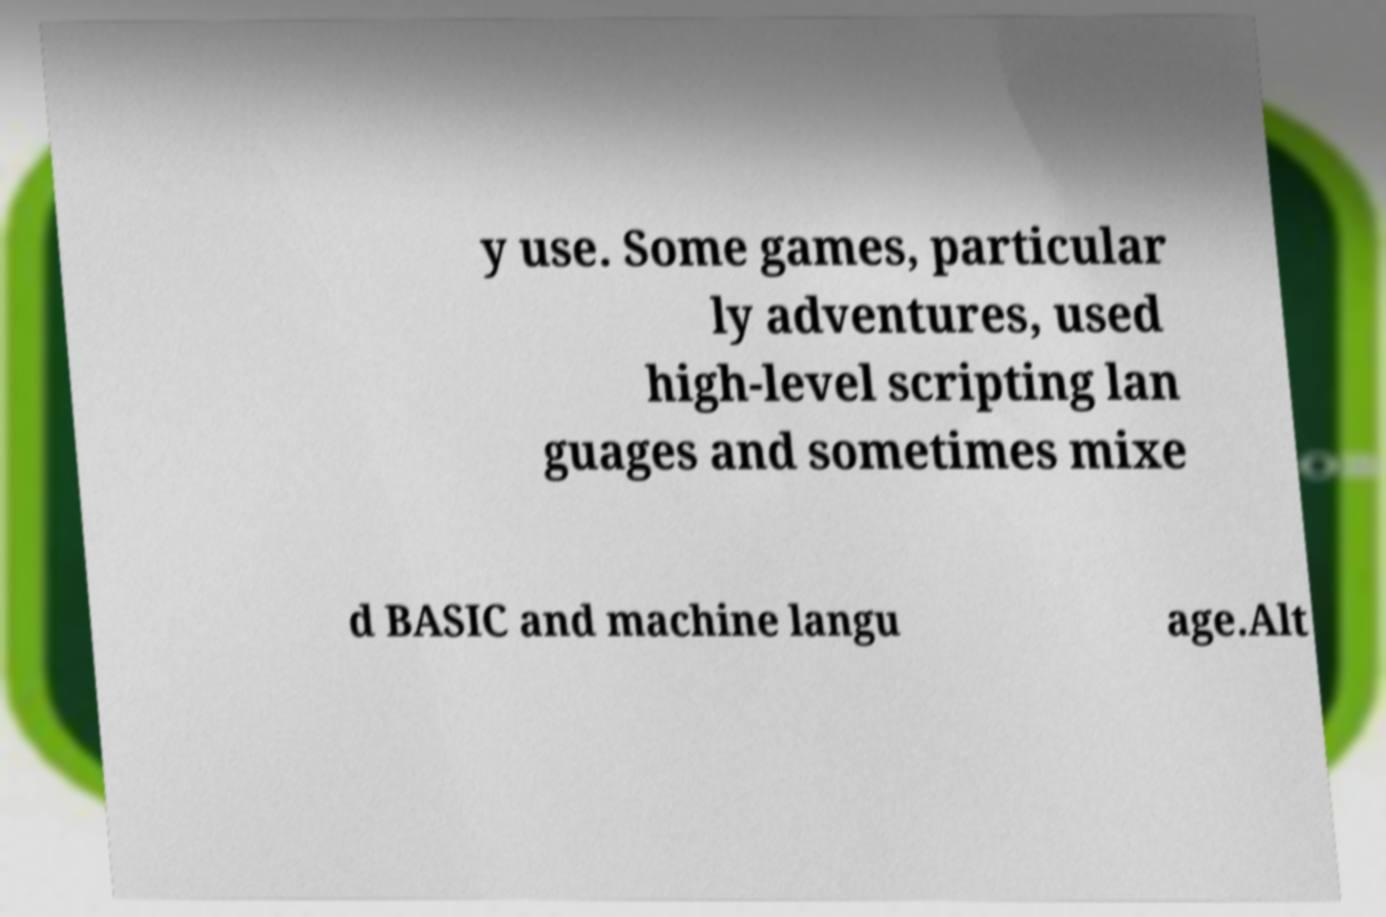Can you read and provide the text displayed in the image?This photo seems to have some interesting text. Can you extract and type it out for me? y use. Some games, particular ly adventures, used high-level scripting lan guages and sometimes mixe d BASIC and machine langu age.Alt 